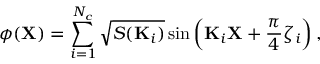<formula> <loc_0><loc_0><loc_500><loc_500>\phi ( X ) = \sum _ { i = 1 } ^ { N _ { c } } \sqrt { S ( K _ { i } ) } \sin \left ( K _ { i } X + \frac { \pi } { 4 } \zeta _ { i } \right ) ,</formula> 